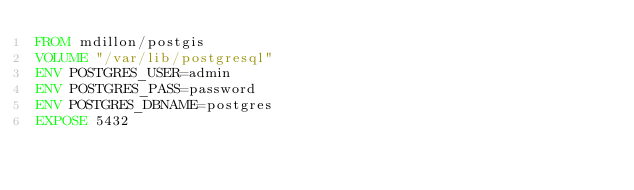<code> <loc_0><loc_0><loc_500><loc_500><_Dockerfile_>FROM mdillon/postgis
VOLUME "/var/lib/postgresql"
ENV POSTGRES_USER=admin
ENV POSTGRES_PASS=password
ENV POSTGRES_DBNAME=postgres
EXPOSE 5432

</code> 